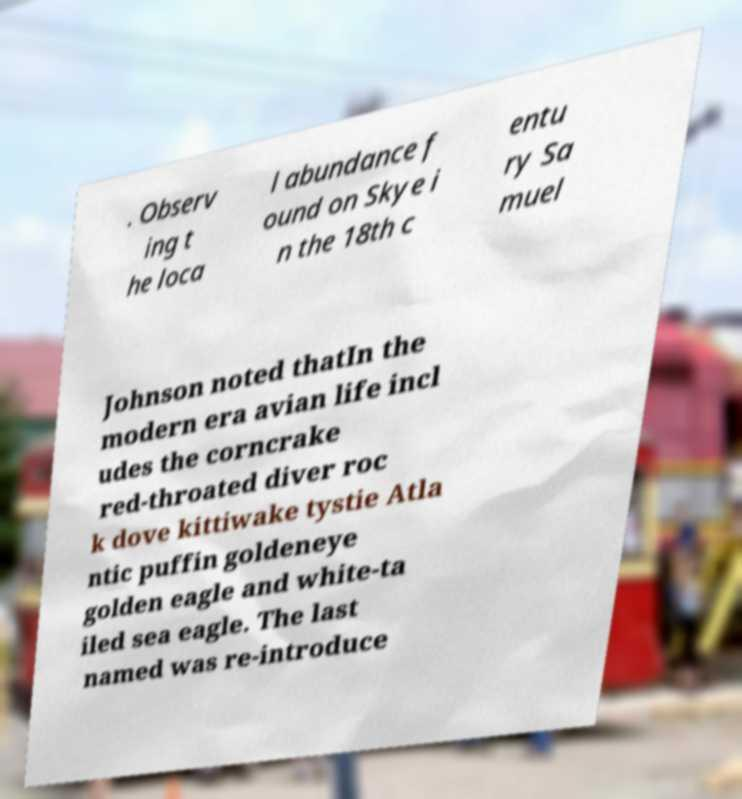Please identify and transcribe the text found in this image. . Observ ing t he loca l abundance f ound on Skye i n the 18th c entu ry Sa muel Johnson noted thatIn the modern era avian life incl udes the corncrake red-throated diver roc k dove kittiwake tystie Atla ntic puffin goldeneye golden eagle and white-ta iled sea eagle. The last named was re-introduce 